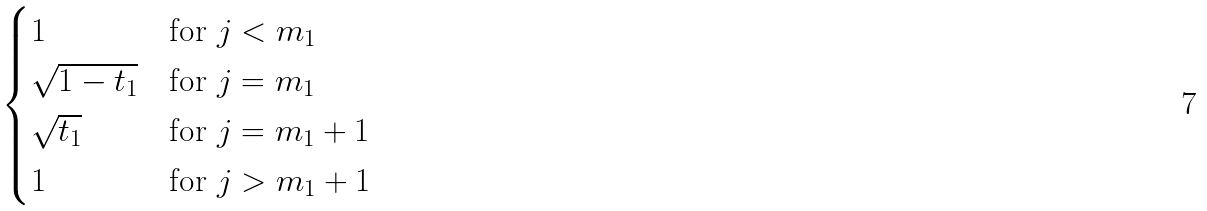<formula> <loc_0><loc_0><loc_500><loc_500>\begin{cases} 1 \quad & \text {for } j < m _ { 1 } \\ \sqrt { 1 - t _ { 1 } } & \text {for } j = m _ { 1 } \\ \sqrt { t _ { 1 } } & \text {for } j = m _ { 1 } + 1 \\ 1 & \text {for } j > m _ { 1 } + 1 \end{cases}</formula> 